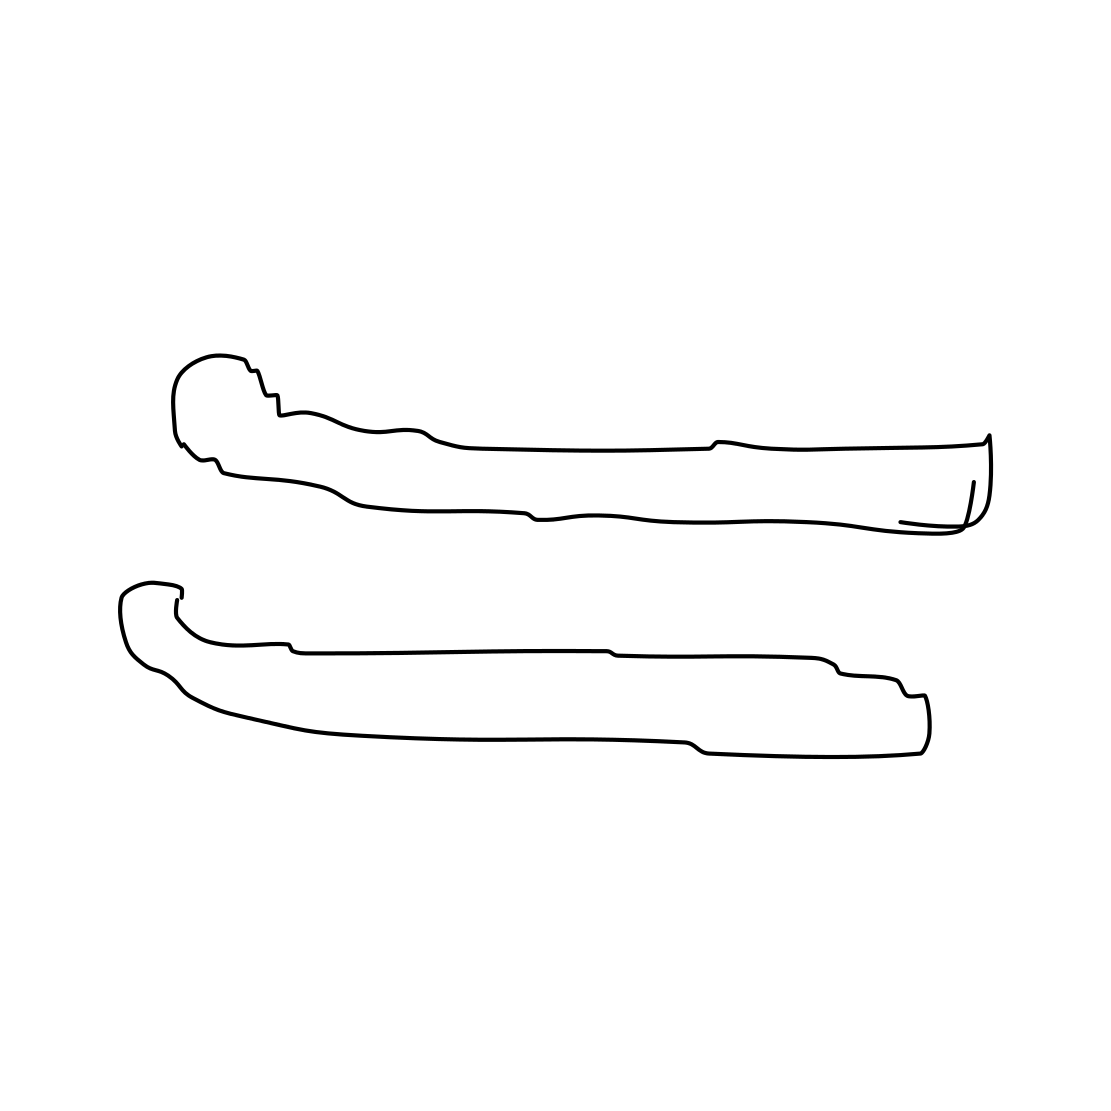Can you tell what these objects might be used for? Based on the image, it's a bit ambiguous, but these could be stylized depictions of tongs or perhaps components of another tool. If they're tongs, they might be used for gripping and lifting materials in a workshop or kitchen setting. The absence of further context makes a definitive answer challenging, but their shapes suggest some type of utility where a secure grip is required. 